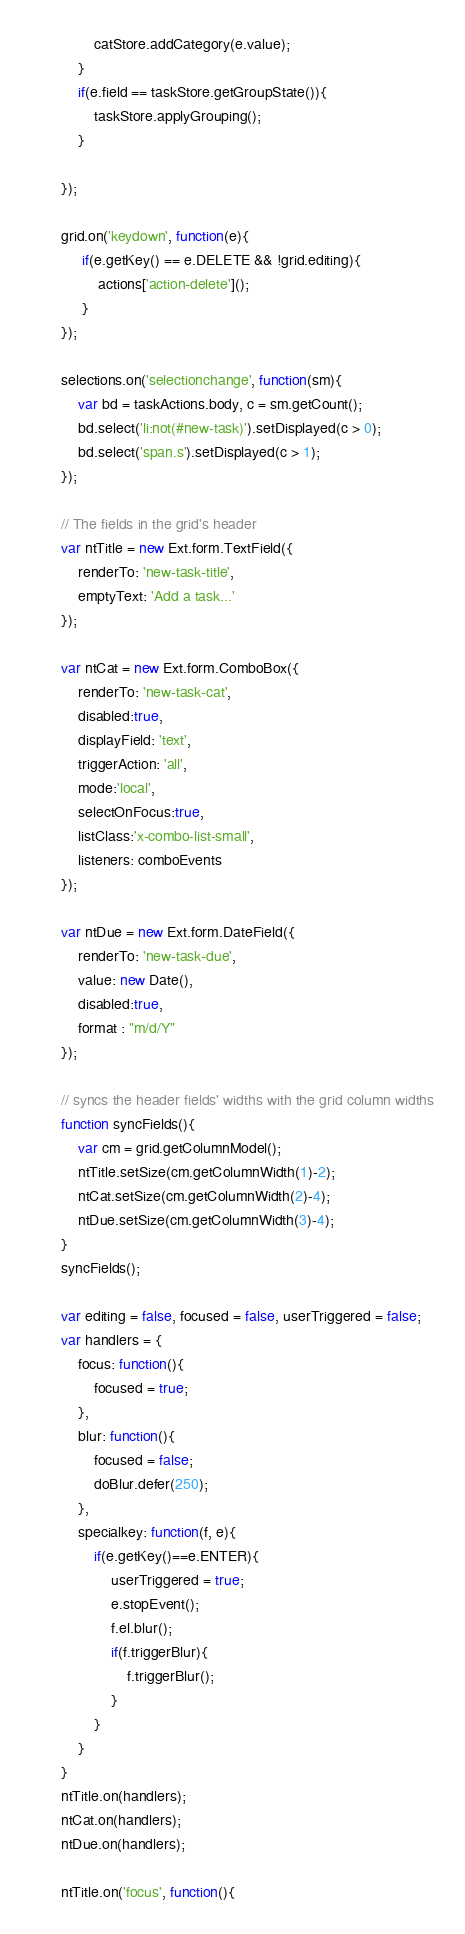<code> <loc_0><loc_0><loc_500><loc_500><_JavaScript_>            catStore.addCategory(e.value);
        }
        if(e.field == taskStore.getGroupState()){
            taskStore.applyGrouping();
        }

    });

    grid.on('keydown', function(e){
         if(e.getKey() == e.DELETE && !grid.editing){
             actions['action-delete']();
         }
    });

    selections.on('selectionchange', function(sm){
    	var bd = taskActions.body, c = sm.getCount();
    	bd.select('li:not(#new-task)').setDisplayed(c > 0);
    	bd.select('span.s').setDisplayed(c > 1);
    });

    // The fields in the grid's header
    var ntTitle = new Ext.form.TextField({
        renderTo: 'new-task-title',
        emptyText: 'Add a task...'
    });

    var ntCat = new Ext.form.ComboBox({
        renderTo: 'new-task-cat',
        disabled:true,
        displayField: 'text',
        triggerAction: 'all',
        mode:'local',
        selectOnFocus:true,
        listClass:'x-combo-list-small',
        listeners: comboEvents
    });

    var ntDue = new Ext.form.DateField({
        renderTo: 'new-task-due',
        value: new Date(),
        disabled:true,
        format : "m/d/Y"
    });

    // syncs the header fields' widths with the grid column widths
    function syncFields(){
        var cm = grid.getColumnModel();
        ntTitle.setSize(cm.getColumnWidth(1)-2);
        ntCat.setSize(cm.getColumnWidth(2)-4);
        ntDue.setSize(cm.getColumnWidth(3)-4);
    }
    syncFields();

    var editing = false, focused = false, userTriggered = false;
    var handlers = {
        focus: function(){
            focused = true;
        },
        blur: function(){
            focused = false;
            doBlur.defer(250);
        },
        specialkey: function(f, e){
            if(e.getKey()==e.ENTER){
                userTriggered = true;
                e.stopEvent();
                f.el.blur();
                if(f.triggerBlur){
                    f.triggerBlur();
                }
            }
        }
    }
    ntTitle.on(handlers);
    ntCat.on(handlers);
    ntDue.on(handlers);

    ntTitle.on('focus', function(){</code> 